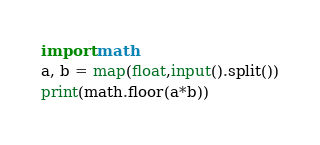Convert code to text. <code><loc_0><loc_0><loc_500><loc_500><_Python_>import math
a, b = map(float,input().split())
print(math.floor(a*b))</code> 